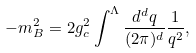Convert formula to latex. <formula><loc_0><loc_0><loc_500><loc_500>- m _ { B } ^ { 2 } = 2 g _ { c } ^ { 2 } \int ^ { \Lambda } \frac { d ^ { d } q } { ( 2 \pi ) ^ { d } } \frac { 1 } { q ^ { 2 } } ,</formula> 